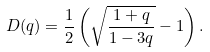<formula> <loc_0><loc_0><loc_500><loc_500>D ( q ) = \frac { 1 } { 2 } \left ( \sqrt { \frac { 1 + q } { 1 - 3 q } } - 1 \right ) .</formula> 